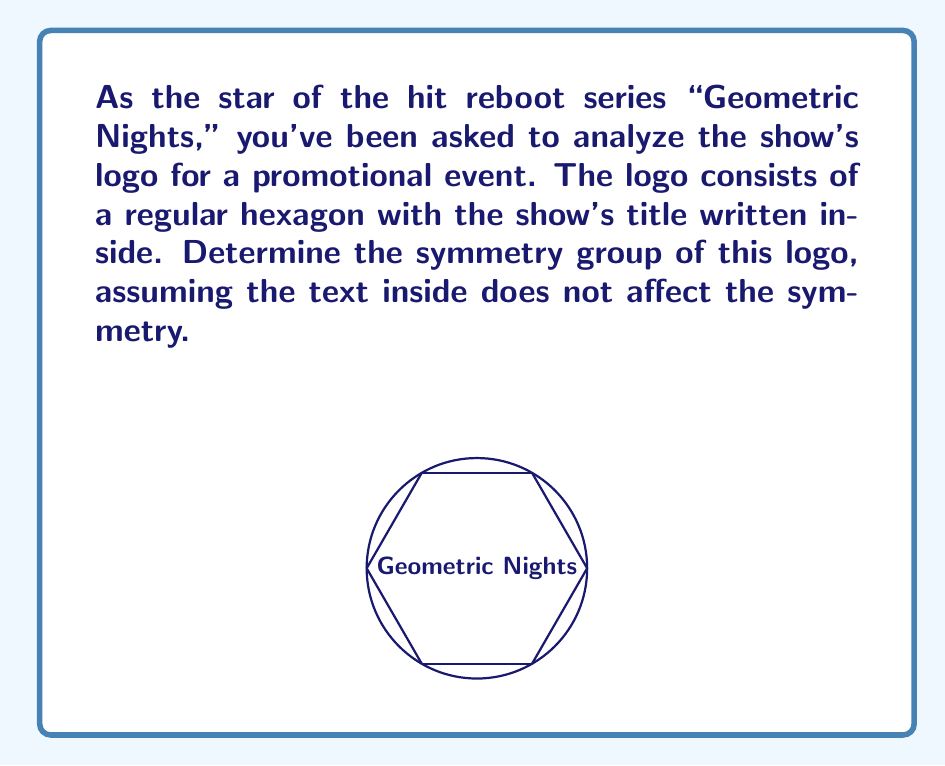Provide a solution to this math problem. To determine the symmetry group of the logo, we need to consider all the transformations that leave the hexagon unchanged. Let's approach this step-by-step:

1) Rotational symmetries:
   - The hexagon has 6-fold rotational symmetry, meaning it can be rotated by multiples of 60° (or $\frac{\pi}{3}$ radians) and remain unchanged.
   - These rotations form a cyclic group of order 6, denoted as $C_6$.

2) Reflection symmetries:
   - The hexagon has 6 lines of reflection symmetry: 3 passing through opposite vertices and 3 passing through the midpoints of opposite sides.

3) The combination of these symmetries forms the dihedral group $D_6$, which is the symmetry group of a regular hexagon.

4) The order of $D_6$ is 12, as it includes:
   - 6 rotations (including the identity rotation)
   - 6 reflections

5) The group structure of $D_6$ can be described by the presentation:
   $$D_6 = \langle r, s \mid r^6 = s^2 = 1, srs = r^{-1} \rangle$$
   where $r$ represents a 60° rotation and $s$ represents a reflection.

6) The elements of $D_6$ can be listed as:
   $$\{1, r, r^2, r^3, r^4, r^5, s, sr, sr^2, sr^3, sr^4, sr^5\}$$

Therefore, the symmetry group of the logo is the dihedral group $D_6$.
Answer: $D_6$ 